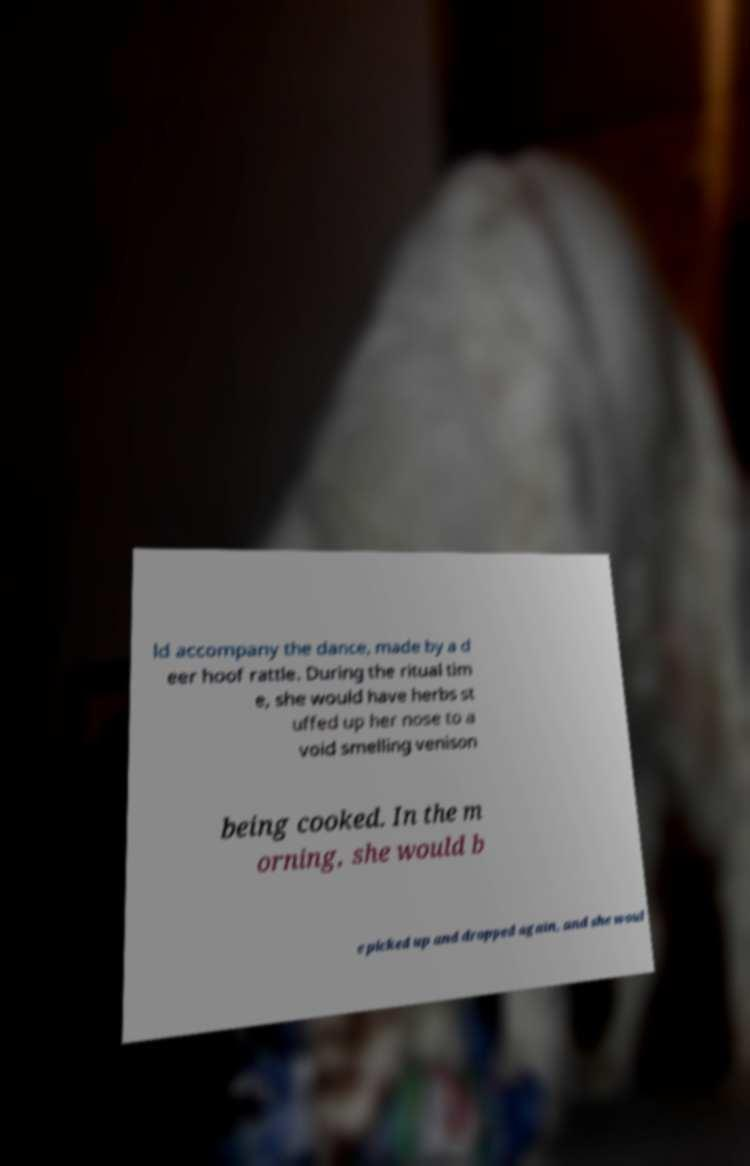Please identify and transcribe the text found in this image. ld accompany the dance, made by a d eer hoof rattle. During the ritual tim e, she would have herbs st uffed up her nose to a void smelling venison being cooked. In the m orning, she would b e picked up and dropped again, and she woul 